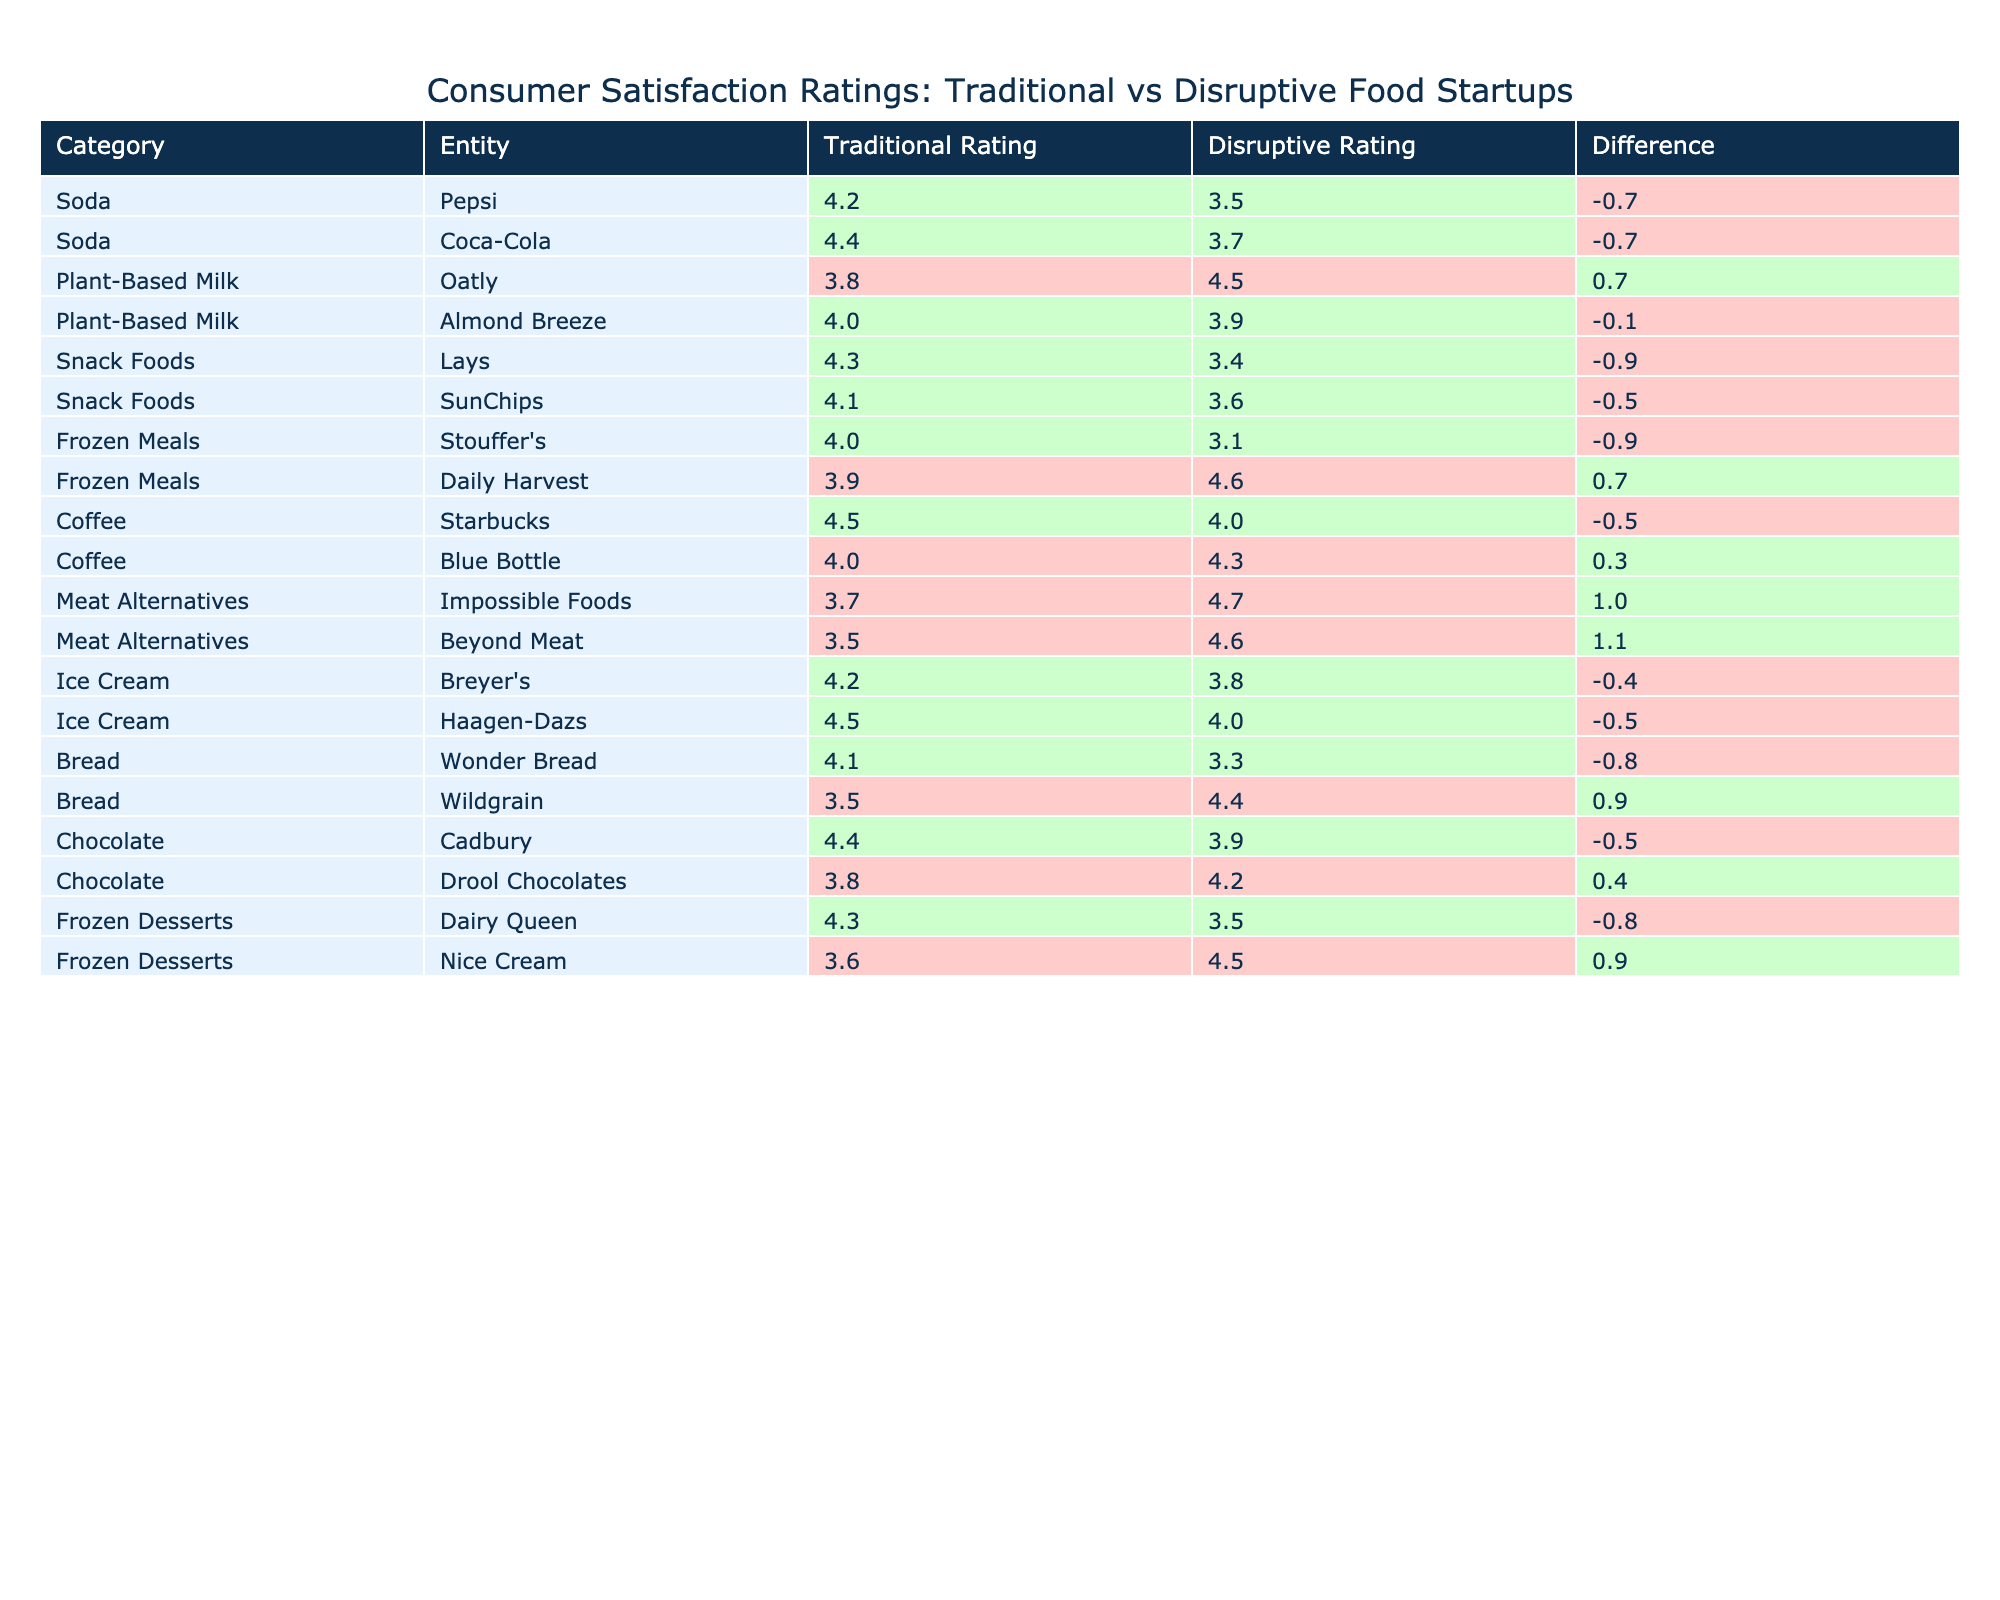What is the highest traditional rating among the traditional food startups listed? The highest traditional rating is found in the Coffee category with Starbucks having a rating of 4.5. I compared the traditional ratings for each entity and found that 4.5 is the maximum value.
Answer: 4.5 Which disruptive food startup has the lowest satisfaction rating? Among the disruptive ratings, the lowest recorded is for Stouffer's, which has a rating of 3.1. I looked through the disruptive ratings for each entity and identified that 3.1 is the minimum value.
Answer: 3.1 What is the average traditional rating for all categories combined? To calculate the average traditional rating, I sum all traditional ratings (4.2 + 4.4 + 3.8 + 4.0 + 4.3 + 4.1 + 4.0 + 3.9 + 4.5 + 4.0 + 3.7 + 3.5 + 4.2 + 4.5 + 4.1 + 3.5 + 4.4 + 3.8 + 4.3 + 3.6) = 68.0. There are 20 entries, so the average is 68.0 / 20 = 3.4.
Answer: 3.4 Is it true that all traditional startup ratings are higher than the disruptive ratings for soda products? I reviewed the ratings for the soda category specifically: Pepsi’s traditional rating (4.2) is higher than its disruptive rating (3.5), and Coca-Cola’s traditional rating (4.4) is higher than its disruptive rating (3.7). Since in both cases traditional outperformed disruptive, the statement is true.
Answer: Yes Among the meat alternatives, is Impossible Foods rated higher than Beyond Meat in traditional ratings? The traditional rating for Impossible Foods is 3.7, while Beyond Meat has a lower rating of 3.5. Comparing these values confirms that Impossible Foods is rated higher, as 3.7 is greater than 3.5.
Answer: Yes What is the difference in consumer satisfaction ratings for the snack foods category? The traditional rating for Lays is 4.3, while SunChips has a traditional rating of 4.1. To find the difference, I subtract the lower rating from the higher: 4.3 - 4.1 = 0.2. For disruptive ratings, Lays has 3.4, and SunChips has 3.6, leading to a difference of 3.6 - 3.4 = 0.2. Both categories yield the same difference of 0.2.
Answer: 0.2 Which category shows the highest difference between traditional and disruptive ratings? I calculated the difference for each category by subtracting the traditional rating from the disruptive rating. The largest difference occurs in the Meat Alternatives category, where Impossible Foods has a difference of 4.7 - 3.7 = 1.0 and Beyond Meat has 4.6 - 3.5 = 1.1, making the final highest difference 1.1.
Answer: 1.1 How many entities have a traditional rating higher than 4.0? I reviewed each traditional rating and counted the entities with ratings above 4.0: Pepsi, Coca-Cola, Lays, SunChips, Starbucks, Haagen-Dazs, and Cadbury, which gives a total of 7 entities with traditional ratings higher than 4.0.
Answer: 7 In the frozen meals category, is Daily Harvest rated higher than Stouffer's in the disruptive ratings? The disruptive rating for Daily Harvest is 4.6, which is indeed higher than Stouffer's disruptive rating of 3.1. Thus the answer is confirmed by comparing these two specific ratings.
Answer: Yes 